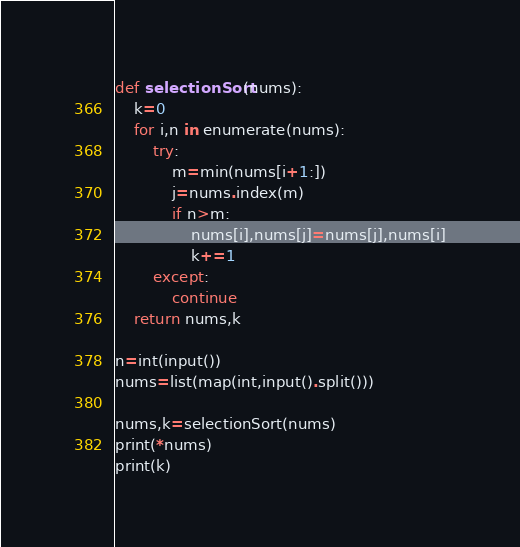<code> <loc_0><loc_0><loc_500><loc_500><_Python_>def selectionSort(nums):
    k=0
    for i,n in enumerate(nums):
        try:
            m=min(nums[i+1:])
            j=nums.index(m)
            if n>m:
                nums[i],nums[j]=nums[j],nums[i]
                k+=1
        except:
            continue
    return nums,k
    
n=int(input())
nums=list(map(int,input().split()))

nums,k=selectionSort(nums)
print(*nums)
print(k)</code> 